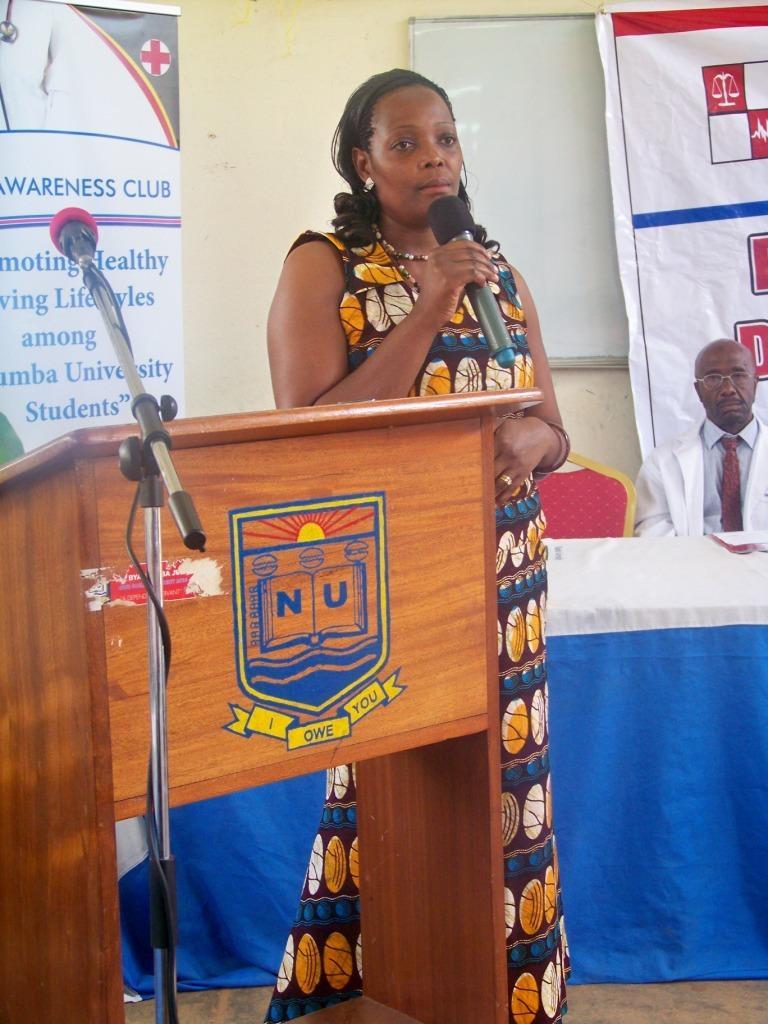Can you describe this image briefly? In this image there is a woman standing. She is holding a microphone in her hand. Beside her there is a wooden podium. There is a logo on the podium. In front of the podium there is a microphone on its stand. Behind her there is a table. There is a cloth spread on the table. There are chairs behind the table. To the right there is a man sitting on the chair. Behind them there is a wall. There are banners hanging on the wall. In the center there is a whiteboard on the wall. 